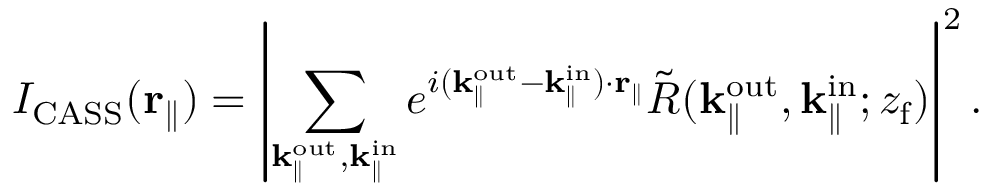<formula> <loc_0><loc_0><loc_500><loc_500>I _ { C A S S } ( r _ { \| } ) = \left | \sum _ { k _ { \| } ^ { o u t } , k _ { \| } ^ { i n } } e ^ { i ( k _ { \| } ^ { o u t } - k _ { \| } ^ { i n } ) \cdot r _ { \| } } \tilde { R } ( { k _ { \| } ^ { o u t } } , k _ { \| } ^ { i n } ; { z _ { f } } ) \right | ^ { 2 } .</formula> 